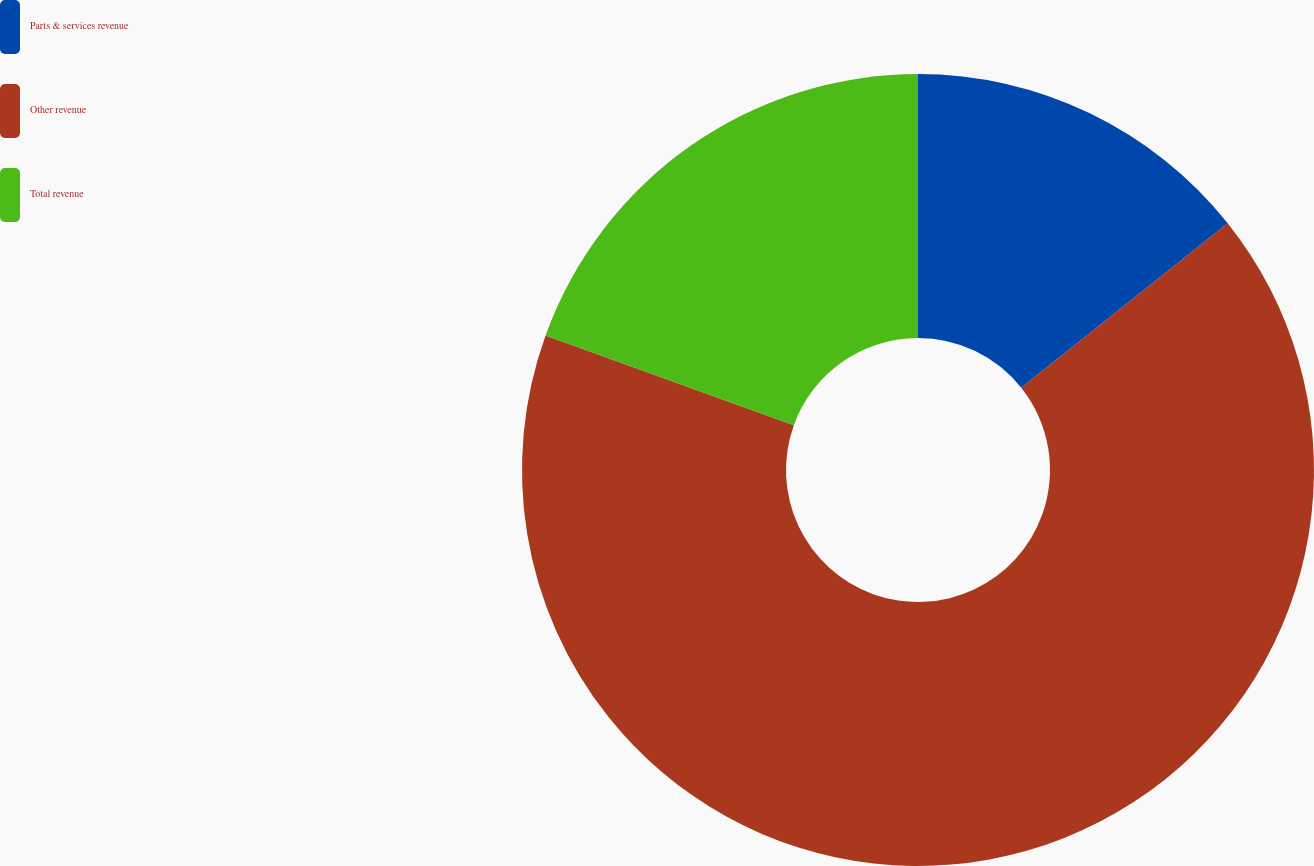<chart> <loc_0><loc_0><loc_500><loc_500><pie_chart><fcel>Parts & services revenue<fcel>Other revenue<fcel>Total revenue<nl><fcel>14.29%<fcel>66.23%<fcel>19.48%<nl></chart> 